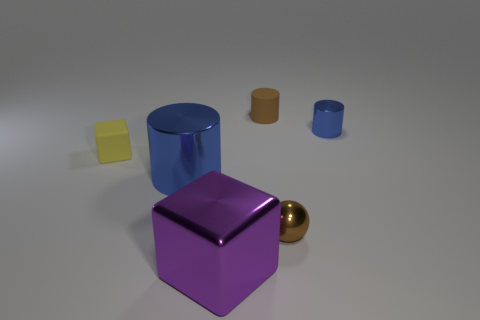There is a blue thing that is the same size as the yellow matte object; what is its shape? The blue object of the same size as the yellow matte one is cylindrical in shape, featuring a curved surface and circular ends, characteristic of cylinders. 